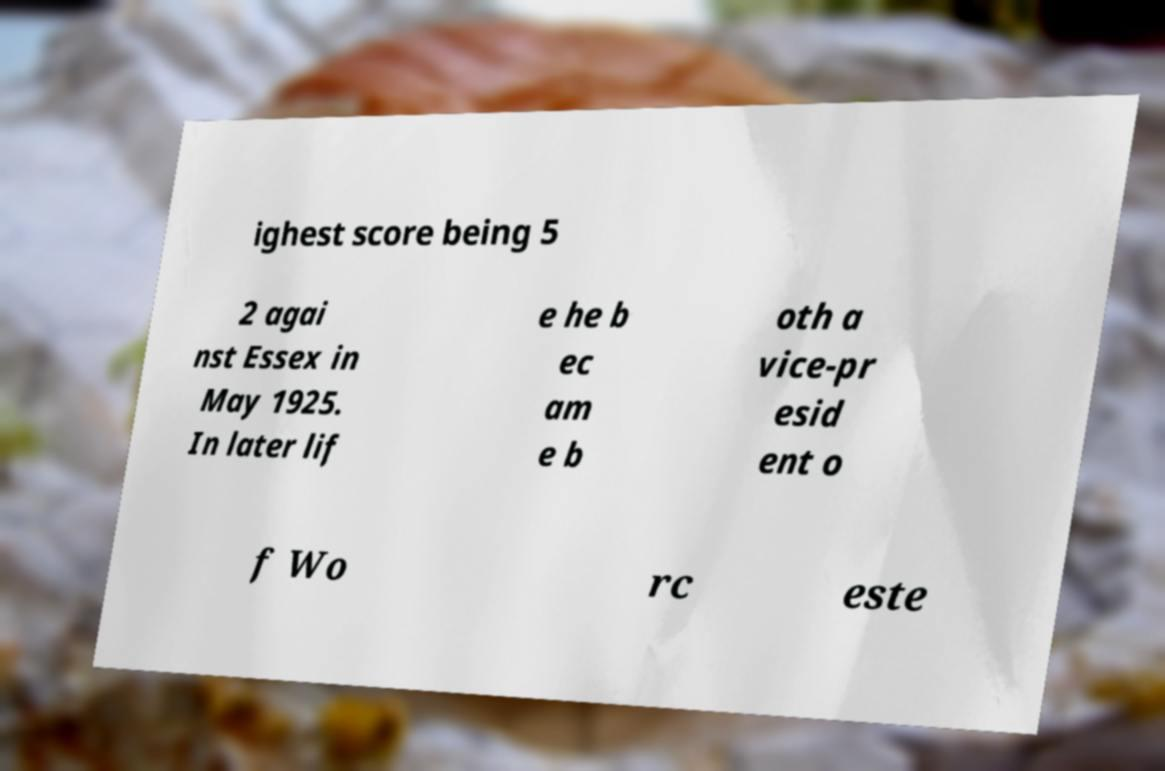For documentation purposes, I need the text within this image transcribed. Could you provide that? ighest score being 5 2 agai nst Essex in May 1925. In later lif e he b ec am e b oth a vice-pr esid ent o f Wo rc este 